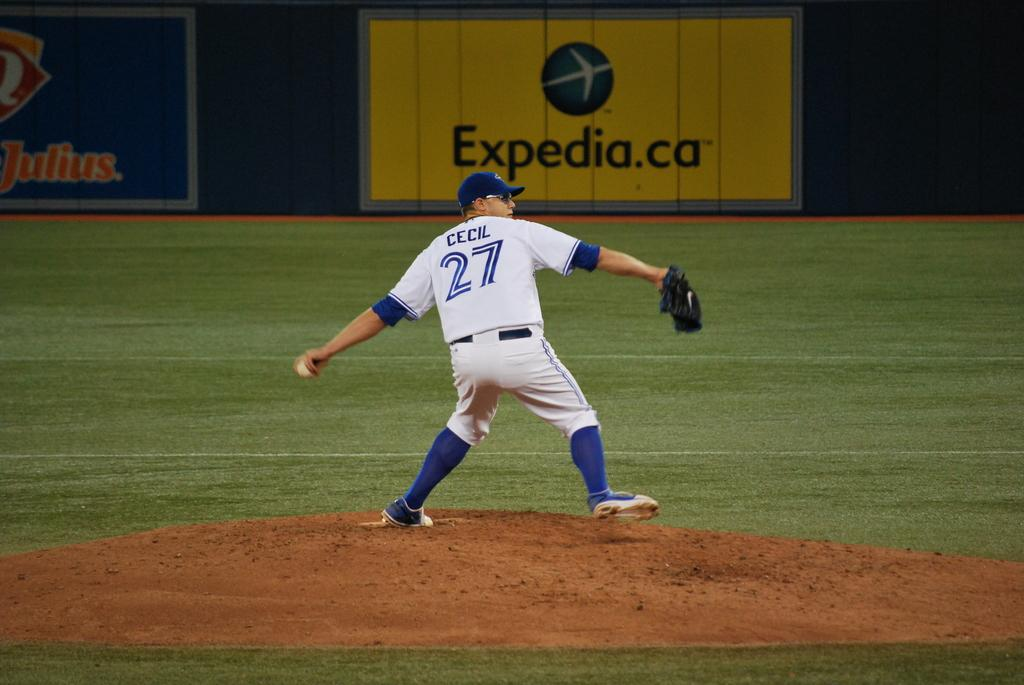<image>
Summarize the visual content of the image. A pitcher named Cecil pitches in front of Expedia sign. 